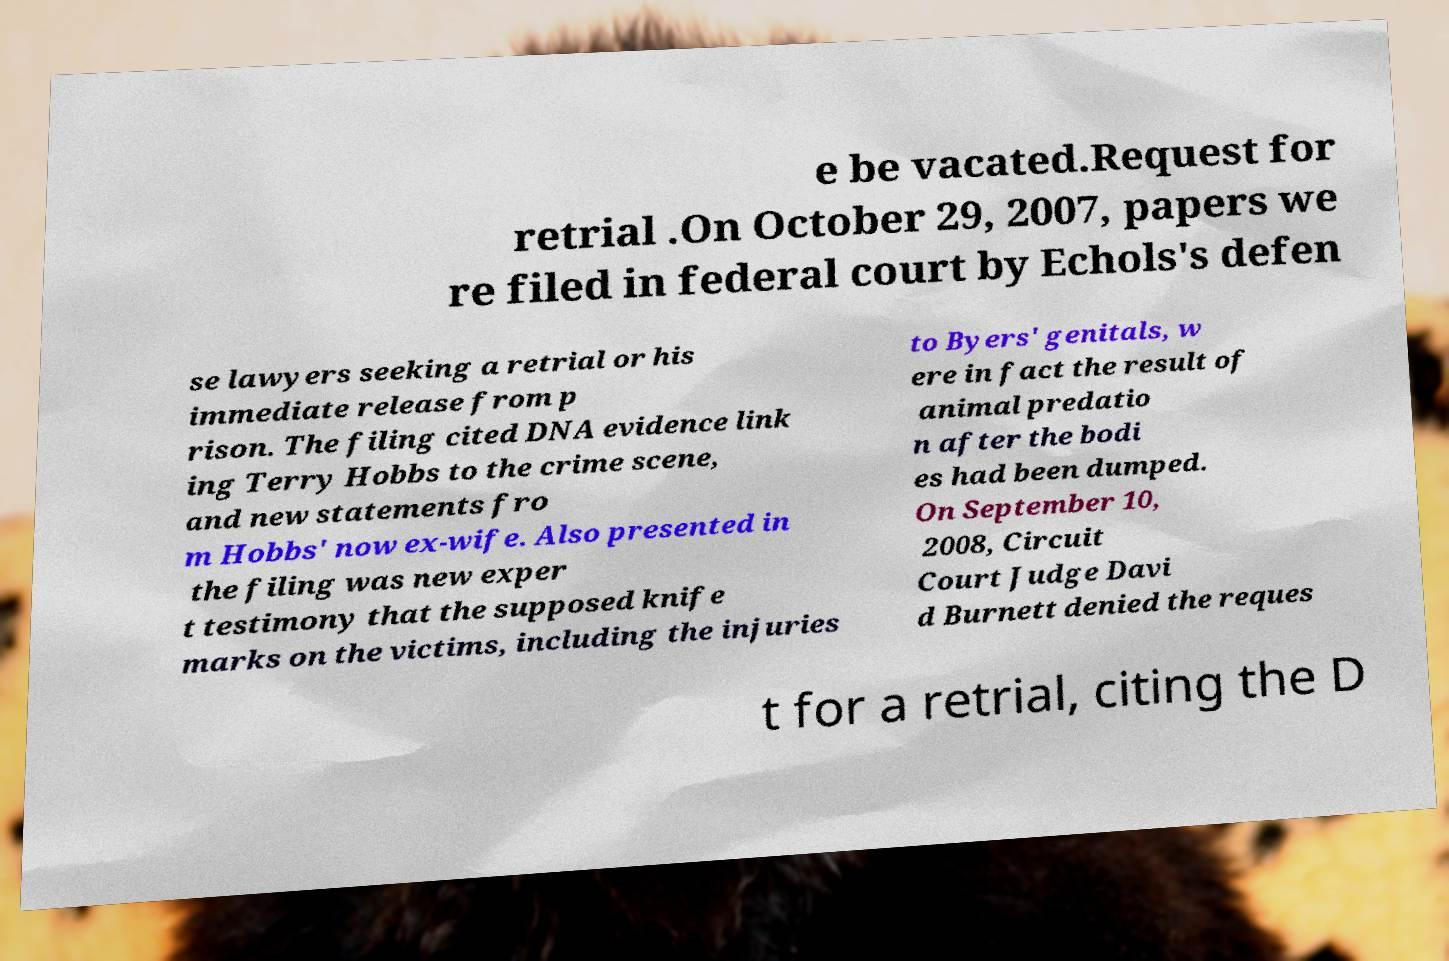I need the written content from this picture converted into text. Can you do that? e be vacated.Request for retrial .On October 29, 2007, papers we re filed in federal court by Echols's defen se lawyers seeking a retrial or his immediate release from p rison. The filing cited DNA evidence link ing Terry Hobbs to the crime scene, and new statements fro m Hobbs' now ex-wife. Also presented in the filing was new exper t testimony that the supposed knife marks on the victims, including the injuries to Byers' genitals, w ere in fact the result of animal predatio n after the bodi es had been dumped. On September 10, 2008, Circuit Court Judge Davi d Burnett denied the reques t for a retrial, citing the D 